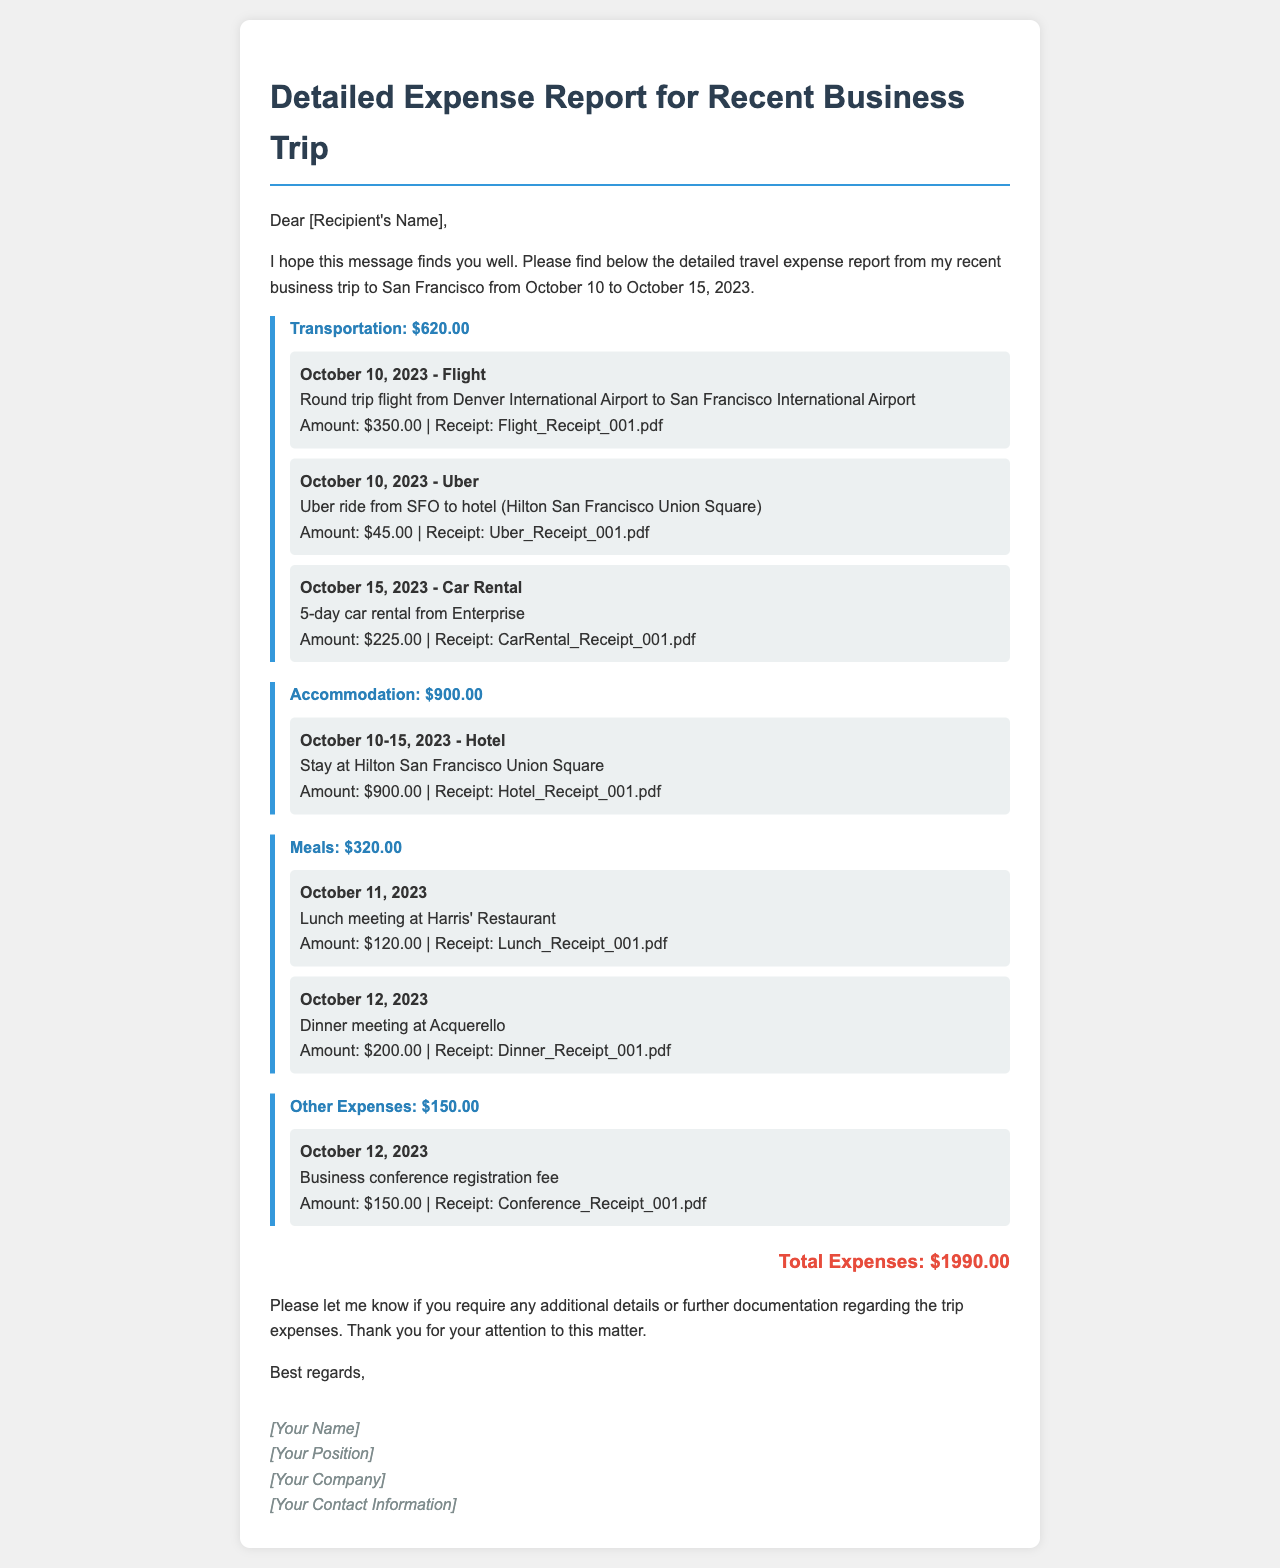what is the total amount for transportation? The total amount for transportation is stated in the category section of the report.
Answer: $620.00 how many days was the hotel stay? The hotel stay duration can be calculated from the check-in and check-out dates provided in the document.
Answer: 5 days what was the amount for the dinner meeting? The amount for the dinner meeting is provided in the meals category of the report.
Answer: $200.00 which hotel was used during the trip? The name of the hotel is mentioned in the accommodation category of the report.
Answer: Hilton San Francisco Union Square what was the registration fee for the business conference? The registration fee is listed under other expenses in the report.
Answer: $150.00 how many meals are listed in the report? The count of meal entries can be determined based on the total number of expense items under the meals category.
Answer: 2 meals when did the business trip occur? The dates of the trip are explicitly stated at the beginning of the document.
Answer: October 10 to October 15, 2023 what type of document is this? The document type is indicated in the title and content of the report.
Answer: Expense report 